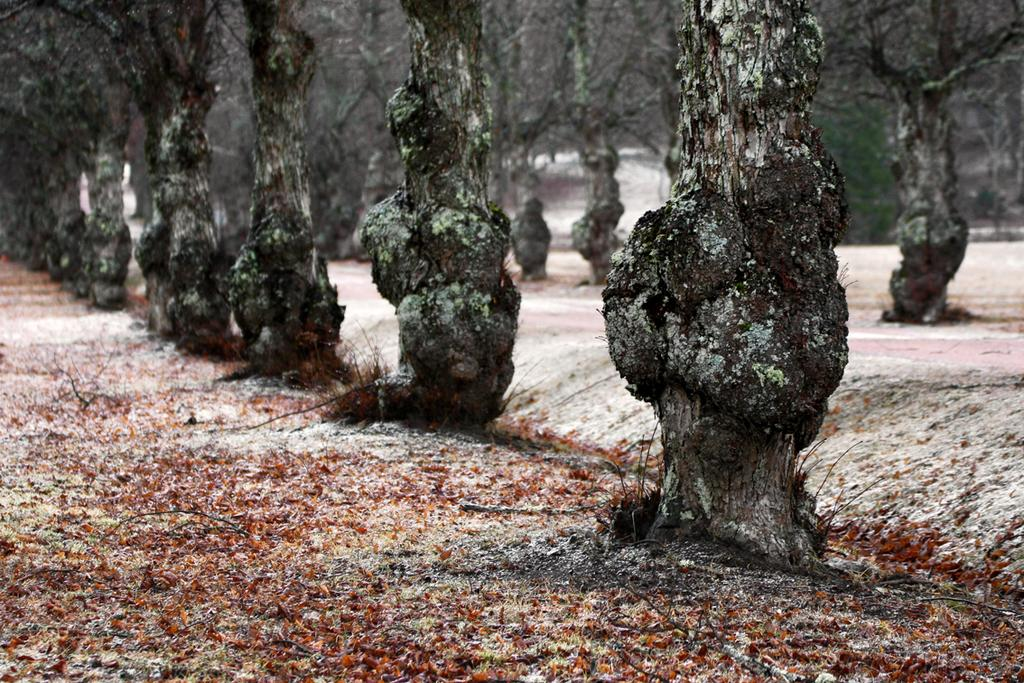What can be seen on the path in the image? There are tree trunks on the path in the image. What structure is visible in the background of the image? There is a house in the background of the image. How many cherries are hanging from the tree trunks in the image? There are no cherries present in the image; it features tree trunks on a path. Is there a donkey walking along the path in the image? There is no donkey present in the image; it only shows tree trunks on the path and a house in the background. 